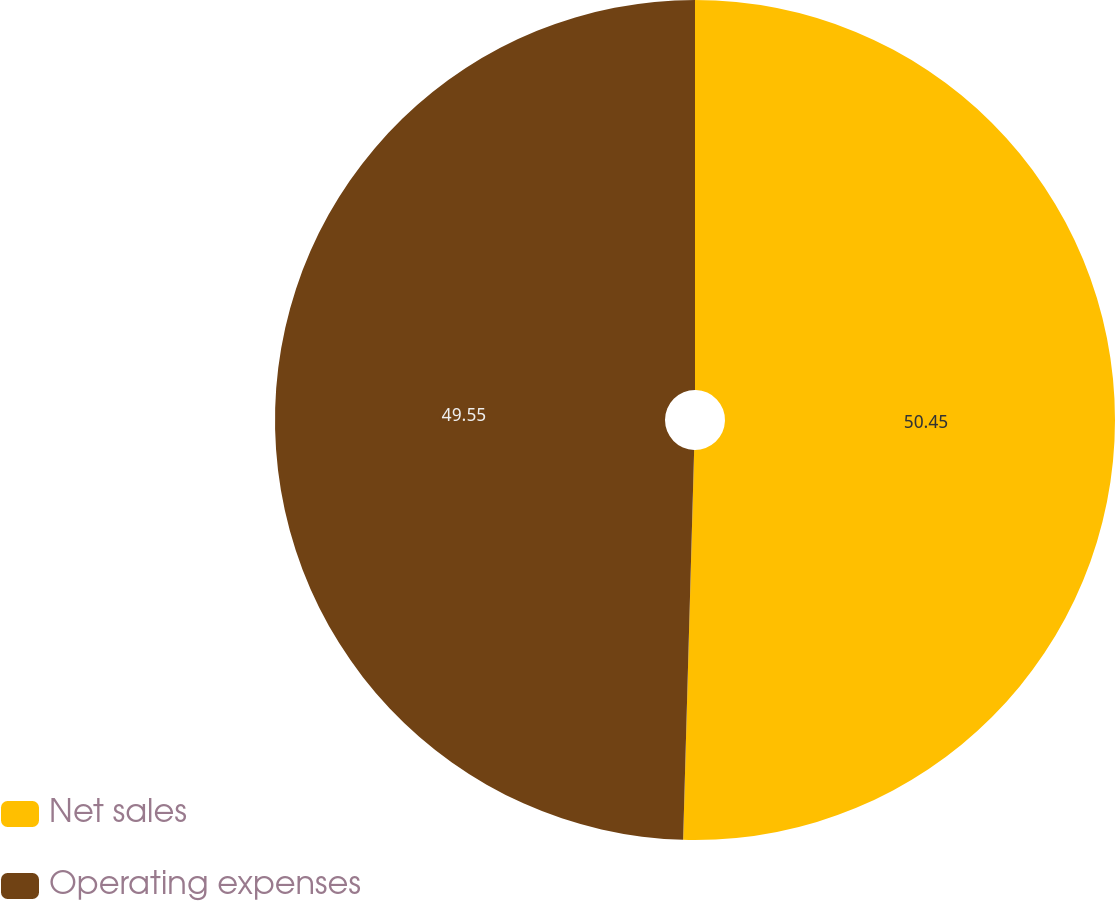Convert chart. <chart><loc_0><loc_0><loc_500><loc_500><pie_chart><fcel>Net sales<fcel>Operating expenses<nl><fcel>50.45%<fcel>49.55%<nl></chart> 